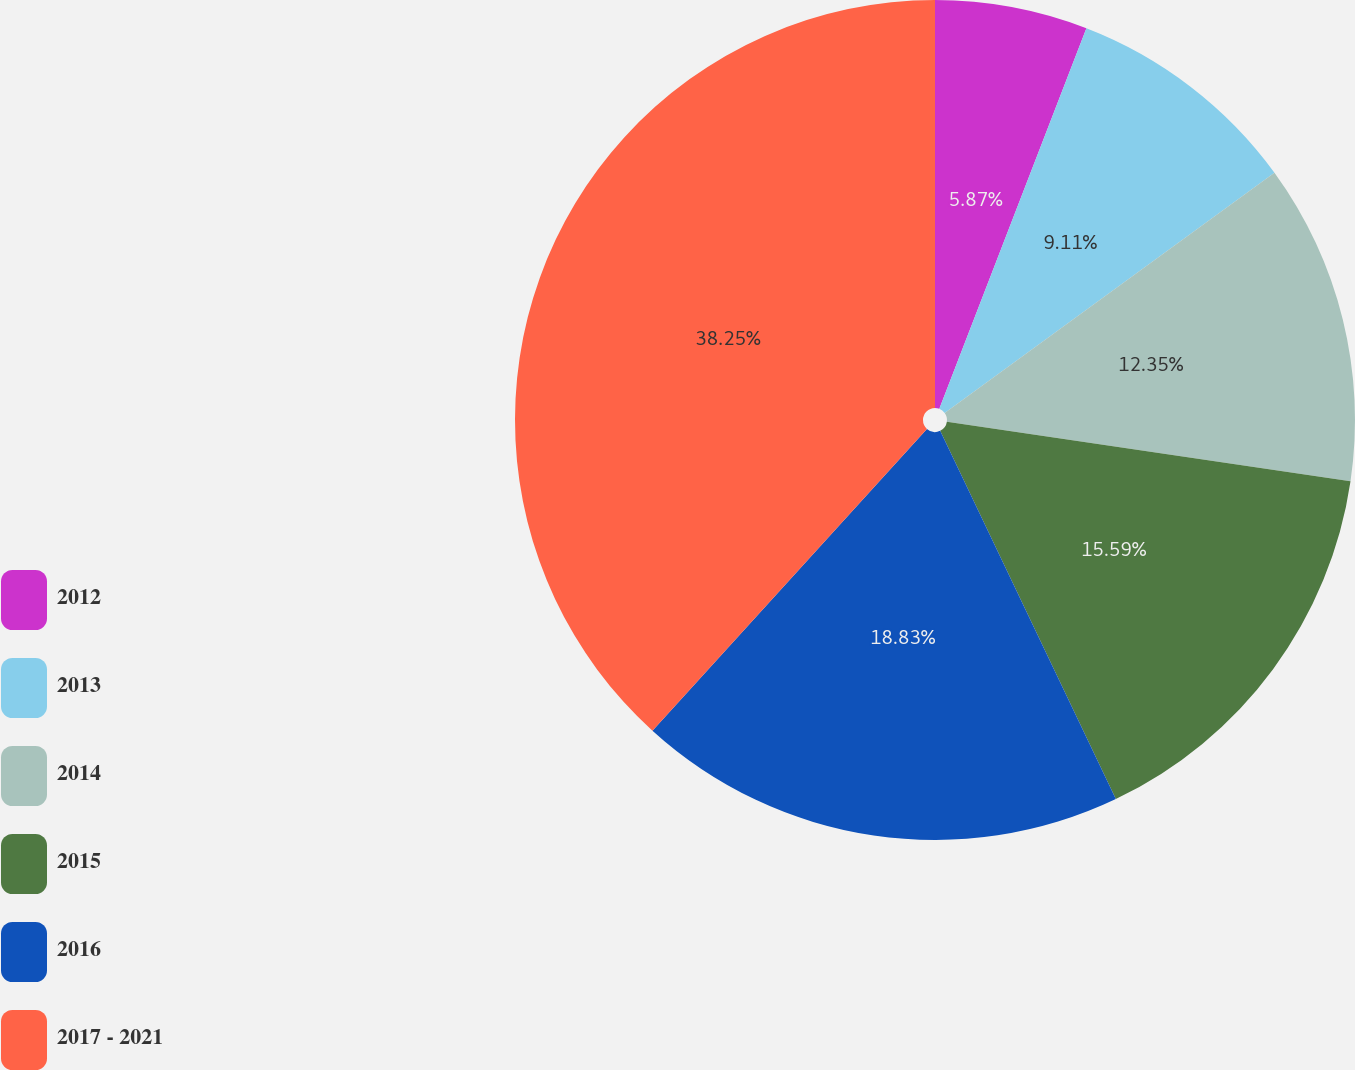<chart> <loc_0><loc_0><loc_500><loc_500><pie_chart><fcel>2012<fcel>2013<fcel>2014<fcel>2015<fcel>2016<fcel>2017 - 2021<nl><fcel>5.87%<fcel>9.11%<fcel>12.35%<fcel>15.59%<fcel>18.83%<fcel>38.26%<nl></chart> 